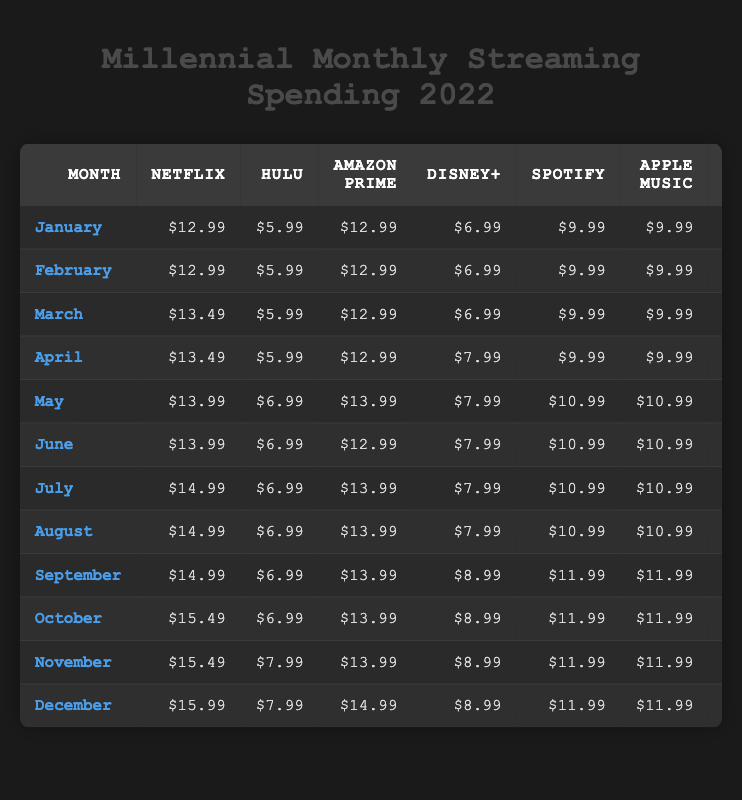What is the total spending for May? Referring to the table, the total spending for May is displayed in the Total column for that month. The value next to May is $94.91.
Answer: $94.91 In which month was the highest amount spent on HBO? By looking at the HBO spending in each month, December shows the highest cost of $18.99.
Answer: December What is the average monthly spending across all months? The total spending for each month can be summed up: $78.92 + $78.92 + $85.40 + $88.41 + $94.91 + $93.91 + $95.91 + $95.91 + $99.91 + $101.41 + $104.41 + $106.91 = $1,079.48. There are 12 months, so the average is $1,079.48 / 12 = $89.95.
Answer: $89.95 Was there any month when the total spending was below $80? By checking the Total column, both January and February have total spending of $78.92, which is below $80.
Answer: Yes How much more was spent on Netflix in October compared to January? The Netflix spending in October is $15.49, and in January it is $12.99. The difference is calculated as $15.49 - $12.99 = $2.50.
Answer: $2.50 What was the difference in total spending between November and December? November's total spending is $104.41 and December's is $106.91. The difference is $106.91 - $104.41 = $2.50.
Answer: $2.50 In which month did the total spending first exceed $90? By examining the Total column, the total for May is $94.91, which is the first instance of exceeding $90, after a total of $88.41 in April.
Answer: May Which streaming service had the highest price in September? In September, HBO had the highest price, listed at $17.99, compared to the prices of other services that month.
Answer: HBO 